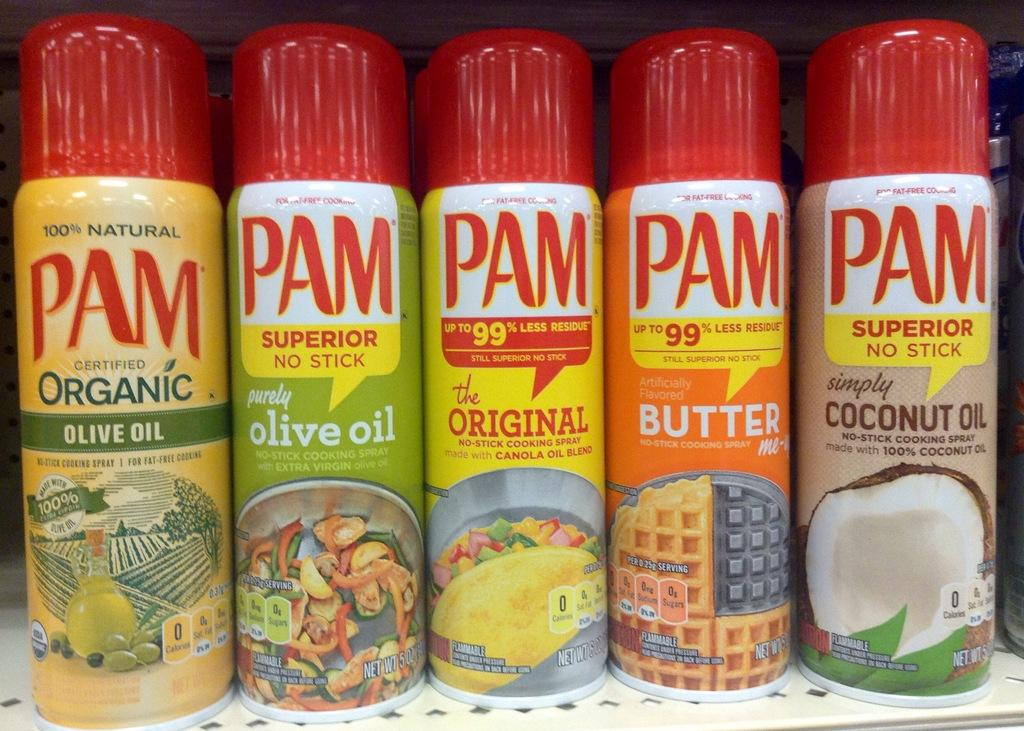How many spray bottles are visible in the image? There are five spray bottles in the image. What can be found on the spray bottles? There is writing on the spray bottles. How many chairs are placed around the wheel in the image? There are no chairs or wheels present in the image; it only features spray bottles with writing on them. 